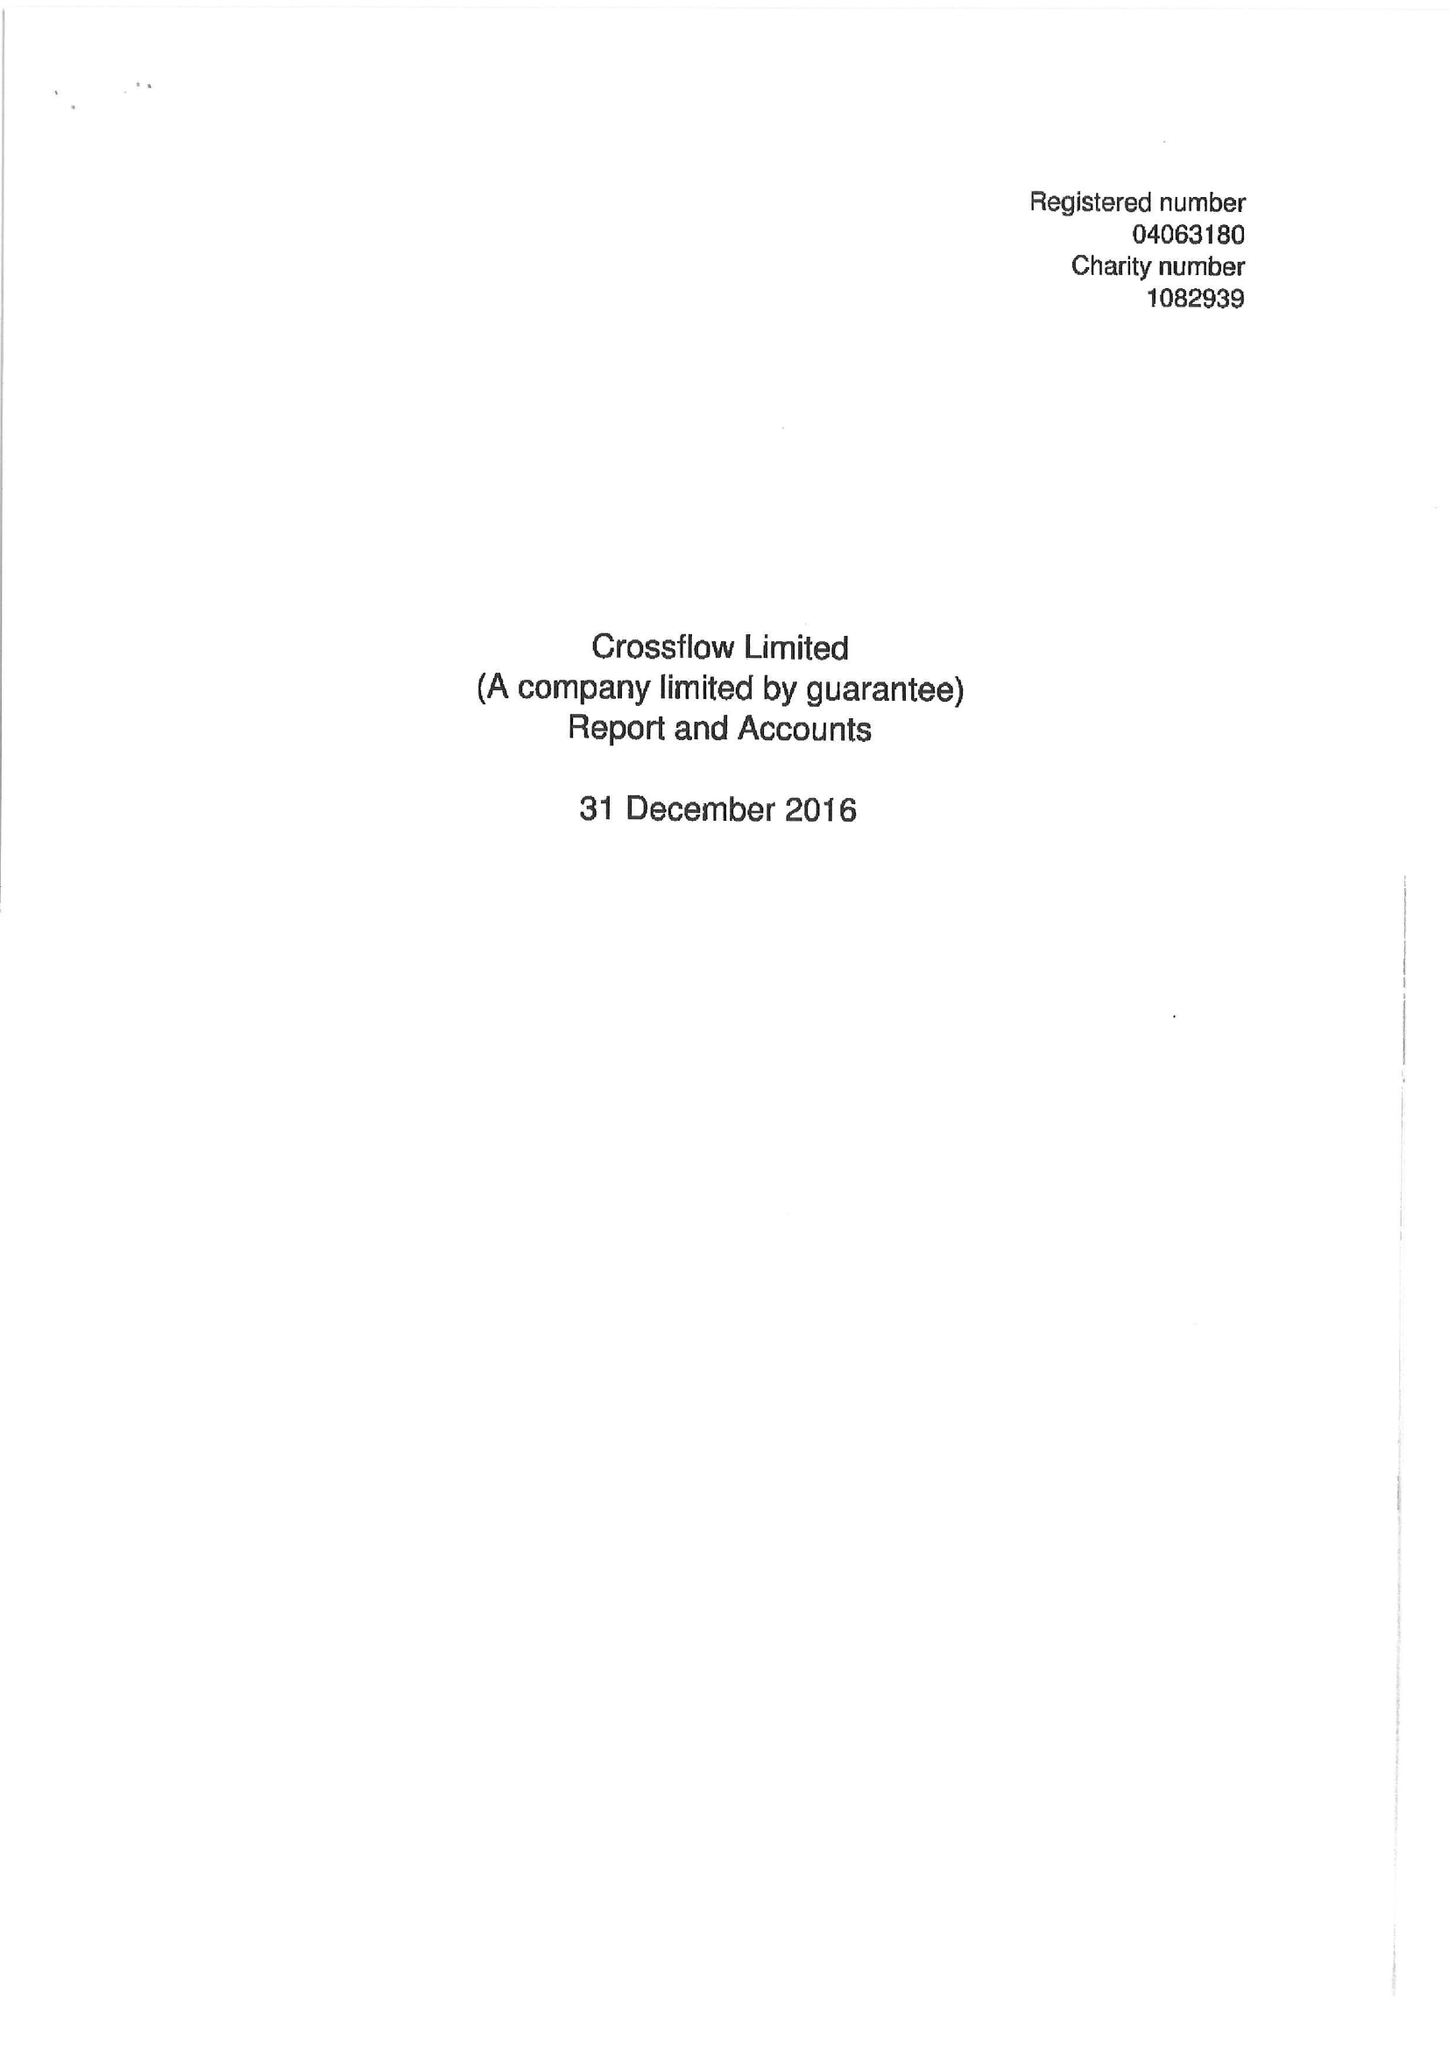What is the value for the charity_name?
Answer the question using a single word or phrase. Crossflow Ltd. 